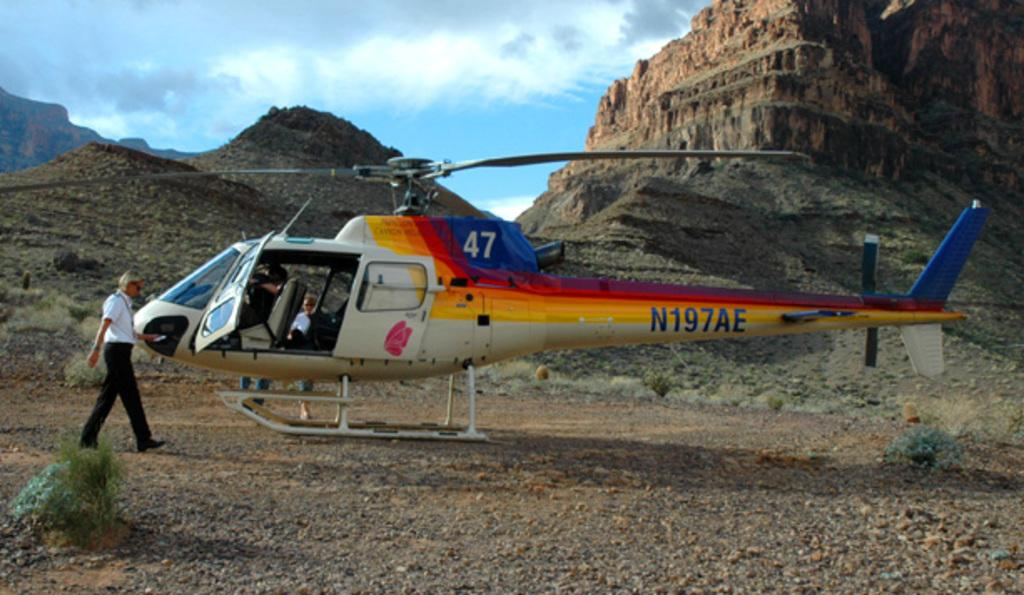<image>
Describe the image concisely. A helicopter that says N197AE on the side that is on the ground surrounded by mountains with a man standing outside, 